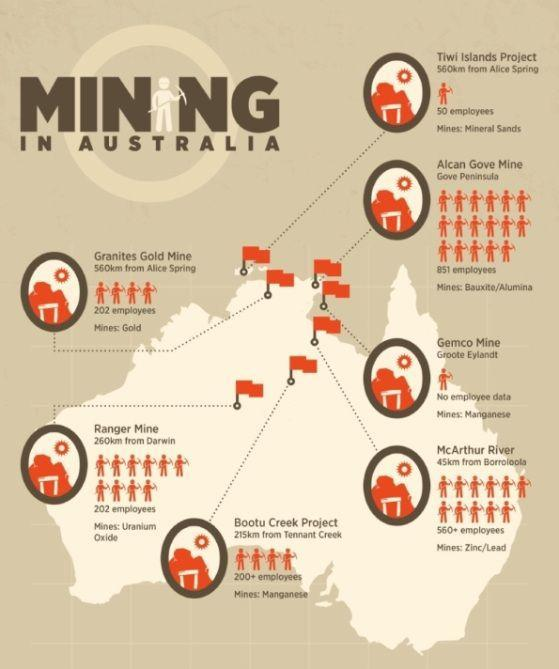How many people work for the Bootu Creek Project?
Answer the question with a short phrase. 200+ employees How many mining locations are shown in the map ? 7 